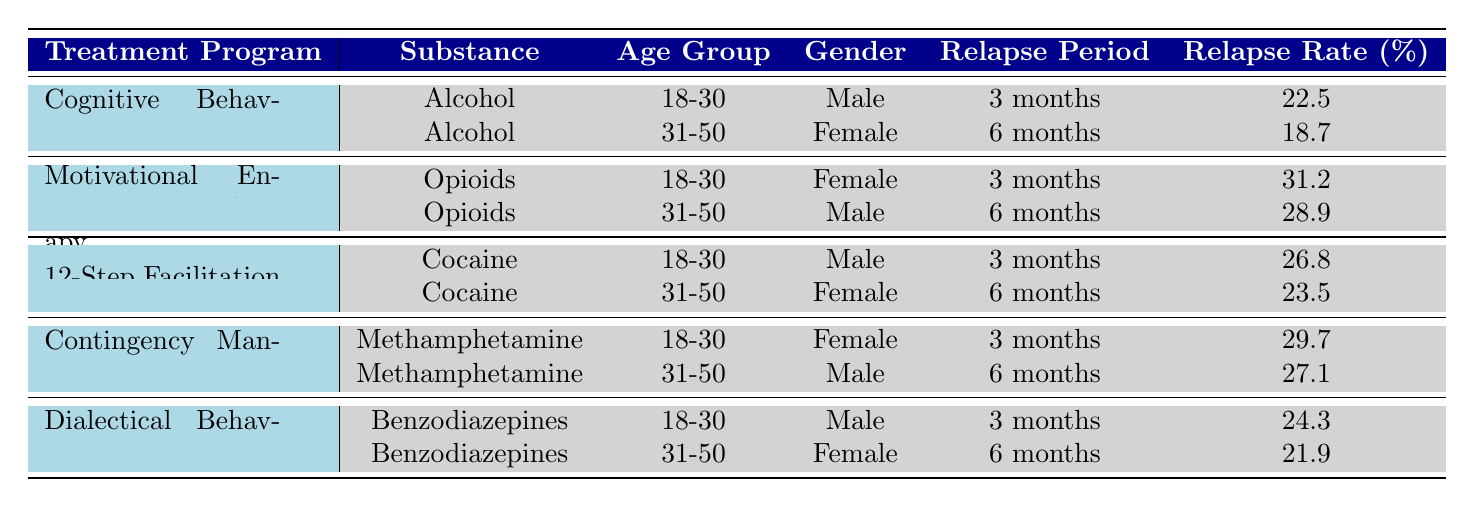What is the relapse rate for Cognitive Behavioral Therapy for alcohol in the 18-30 age group for a 3-month period? Looking at the table under Cognitive Behavioral Therapy for substance Alcohol and age group 18-30, the relapse rate is directly listed as 22.5%.
Answer: 22.5% What is the relapse rate for Dialectical Behavior Therapy when treating Benzodiazepines in the 31-50 age group for a 6-month period? The table specifies that for Dialectical Behavior Therapy treating Benzodiazepines and the 31-50 age group, the relapse rate is 21.9% as it is directly indicated.
Answer: 21.9% Which treatment program has the highest relapse rate for opioids among females aged 18-30 for a 3-month period? Checking the table, the relapse rate for Motivational Enhancement Therapy for opioids in the 18-30 female age group is 31.2%, which is the highest value compared to any other treatment program in that category.
Answer: 31.2% What is the average relapse rate for the 6-month treatment period across all substances? To find the average, sum the relapse rates for the 6-month cases: 18.7 (CBT) + 28.9 (MET) + 23.5 (12-Step) + 27.1 (CM) + 21.9 (DBT) = 120.1%. There are 5 data points, so the average is 120.1/5 = 24.02%.
Answer: 24.02% Does the relapse rate for cocaine in the 31-50 age group for 6 months exceed 25%? Referring to the table, the relapse rate for 12-Step Facilitation treating cocaine in the 31-50 age group is 23.5%, which does not exceed 25%.
Answer: No Is the relapse rate for Methamphetamine treatment higher for the 18-30 age group than for the 31-50 age group under Contingency Management? The relapse rate for Methamphetamine in the 18-30 age group is 29.7%, and for the 31-50 age group, it is 27.1%. Since 29.7 is greater than 27.1, the answer is yes.
Answer: Yes What is the difference in relapse rates between Motivational Enhancement Therapy and 12-Step Facilitation for cocaine in the 18-30 age group? The relapse rate for 12-Step Facilitation is 26.8%, and for Motivational Enhancement Therapy is not applicable here as it does not treat cocaine in this age group. Therefore, calculation cannot be made for this comparison.
Answer: N/A Which treatment has the lowest relapse rate in the 3-month period across all substances? By reviewing the 3-month relapse rates in the table, the lowest value is 22.5% for Cognitive Behavioral Therapy treating Alcohol.
Answer: 22.5% Are there any treatment programs for benzodiazepines that have a relapse rate equal to or greater than 24% in the 3-month period? The relapse rate for Dialectical Behavior Therapy is 24.3%, which is greater than 24%. Thus, the answer to this question is yes since there’s at least one program meeting this criterion.
Answer: Yes 